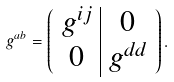Convert formula to latex. <formula><loc_0><loc_0><loc_500><loc_500>g ^ { a b } = \left ( \begin{array} { c | c } g ^ { i j } & 0 \\ 0 & g ^ { d d } \end{array} \right ) .</formula> 